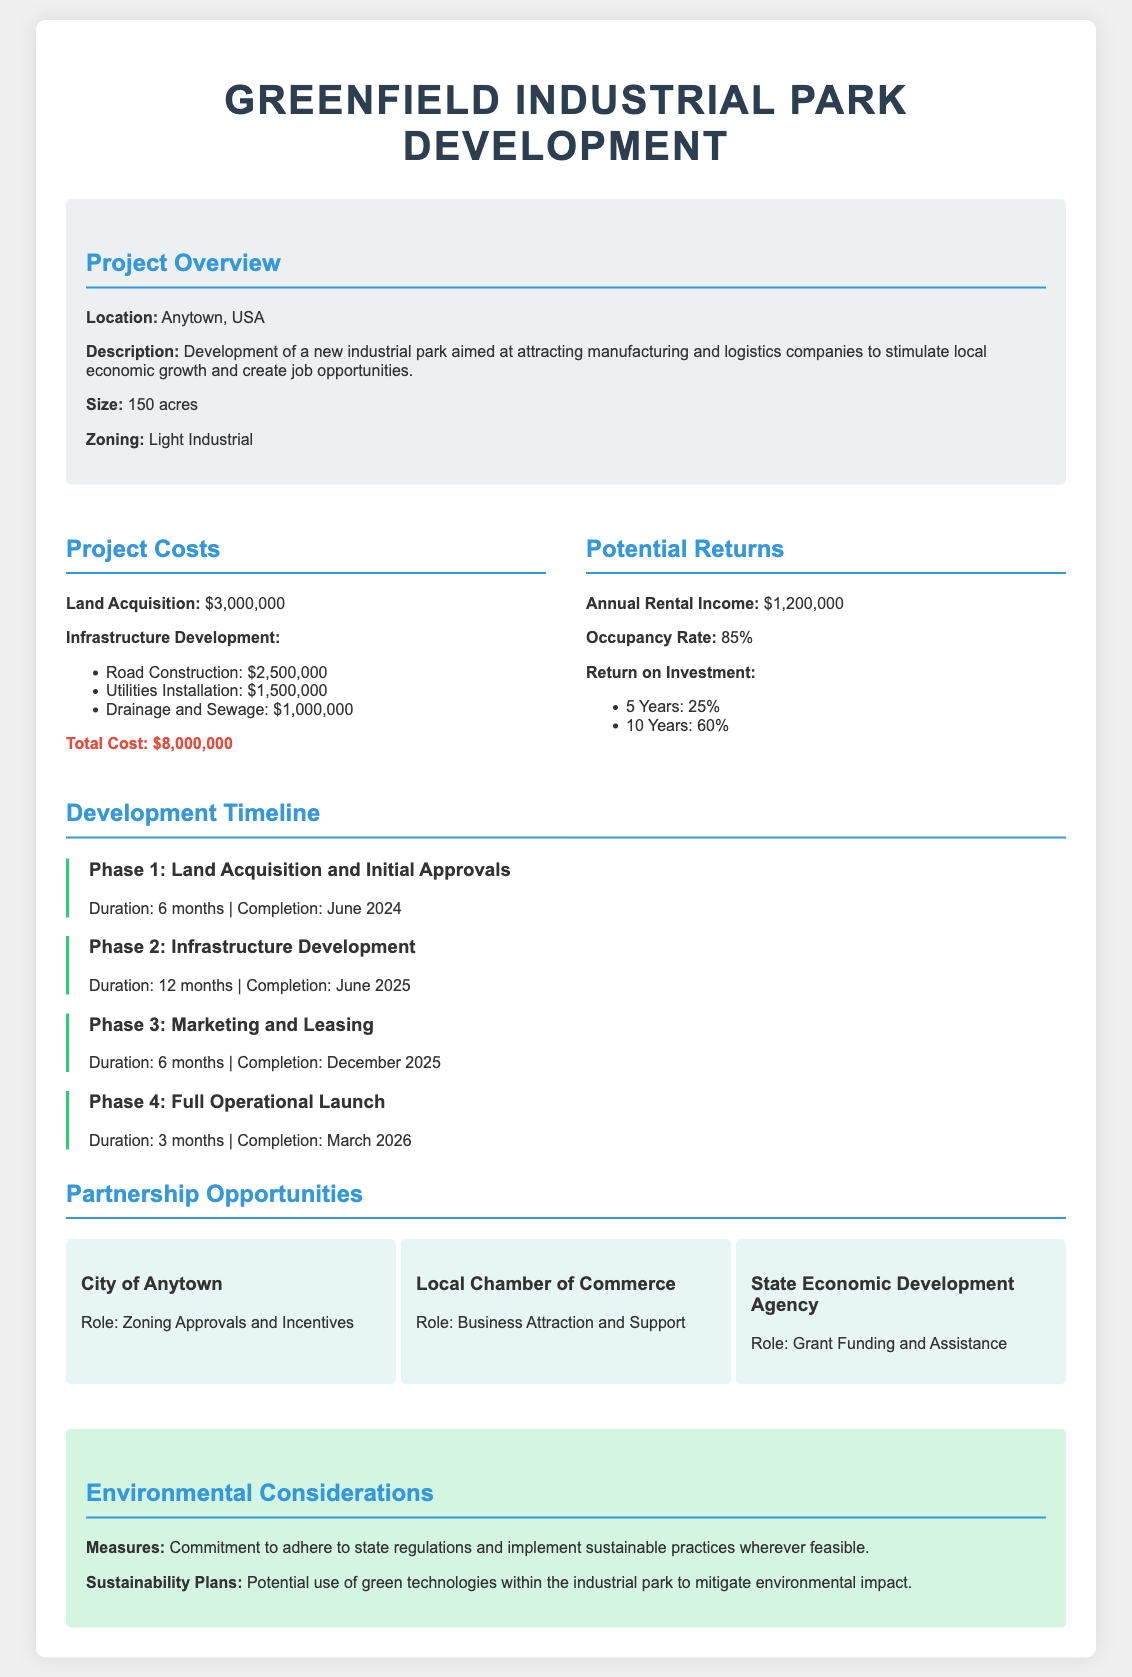What is the total cost of the project? The total cost is mentioned in the document as $8,000,000.
Answer: $8,000,000 What is the annual rental income projected? The document states that the annual rental income is $1,200,000.
Answer: $1,200,000 What is the completion date for Phase 2? The document specifies that Phase 2 will be completed in June 2025.
Answer: June 2025 What is the expected return on investment after 10 years? The document lists the return on investment after 10 years as 60%.
Answer: 60% How large is the industrial park? The size of the industrial park is indicated as 150 acres in the document.
Answer: 150 acres Who is responsible for zoning approvals? The document mentions the City of Anytown as responsible for zoning approvals.
Answer: City of Anytown What is the occupancy rate stated in the proposal? The occupancy rate mentioned in the document is 85%.
Answer: 85% What is the duration of Phase 1? According to the document, the duration of Phase 1 is 6 months.
Answer: 6 months What are the environmental measures mentioned? The document indicates a commitment to adhere to state regulations and implement sustainable practices.
Answer: Adhere to state regulations and implement sustainable practices 